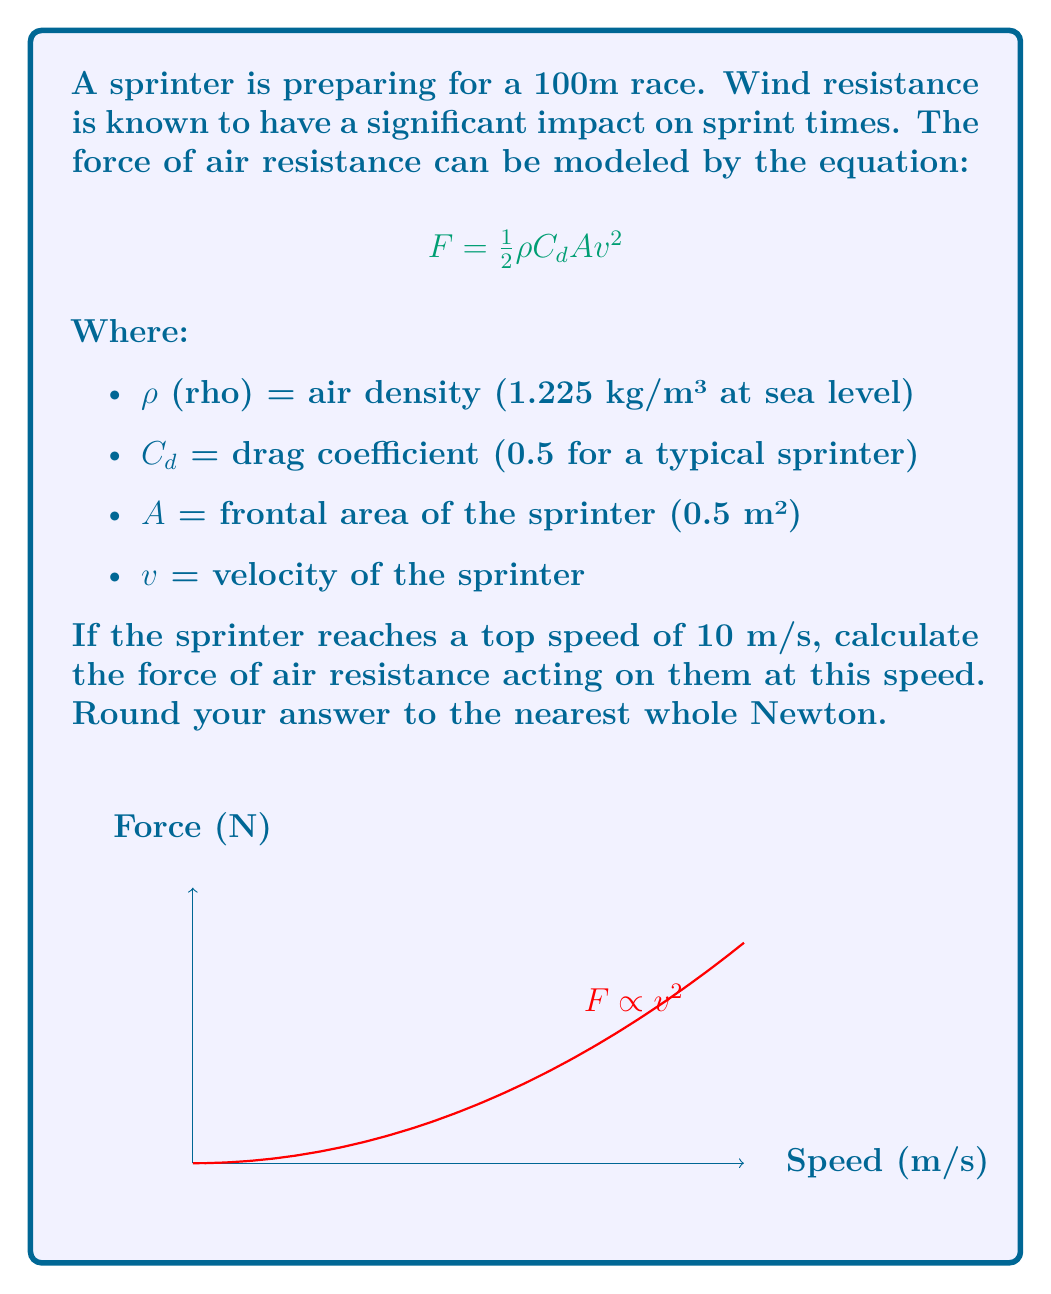Could you help me with this problem? To solve this problem, we'll use the given equation and substitute the known values:

1) The equation for air resistance force is:
   $$F = \frac{1}{2} \rho C_d A v^2$$

2) We know:
   $\rho = 1.225$ kg/m³
   $C_d = 0.5$
   $A = 0.5$ m²
   $v = 10$ m/s

3) Let's substitute these values into the equation:
   $$F = \frac{1}{2} \times 1.225 \times 0.5 \times 0.5 \times 10^2$$

4) First, let's calculate the value inside the parentheses:
   $$F = \frac{1}{2} \times 1.225 \times 0.25 \times 100$$

5) Multiply:
   $$F = \frac{1}{2} \times 30.625$$

6) Final calculation:
   $$F = 15.3125 \text{ N}$$

7) Rounding to the nearest whole Newton:
   $$F \approx 15 \text{ N}$$
Answer: 15 N 